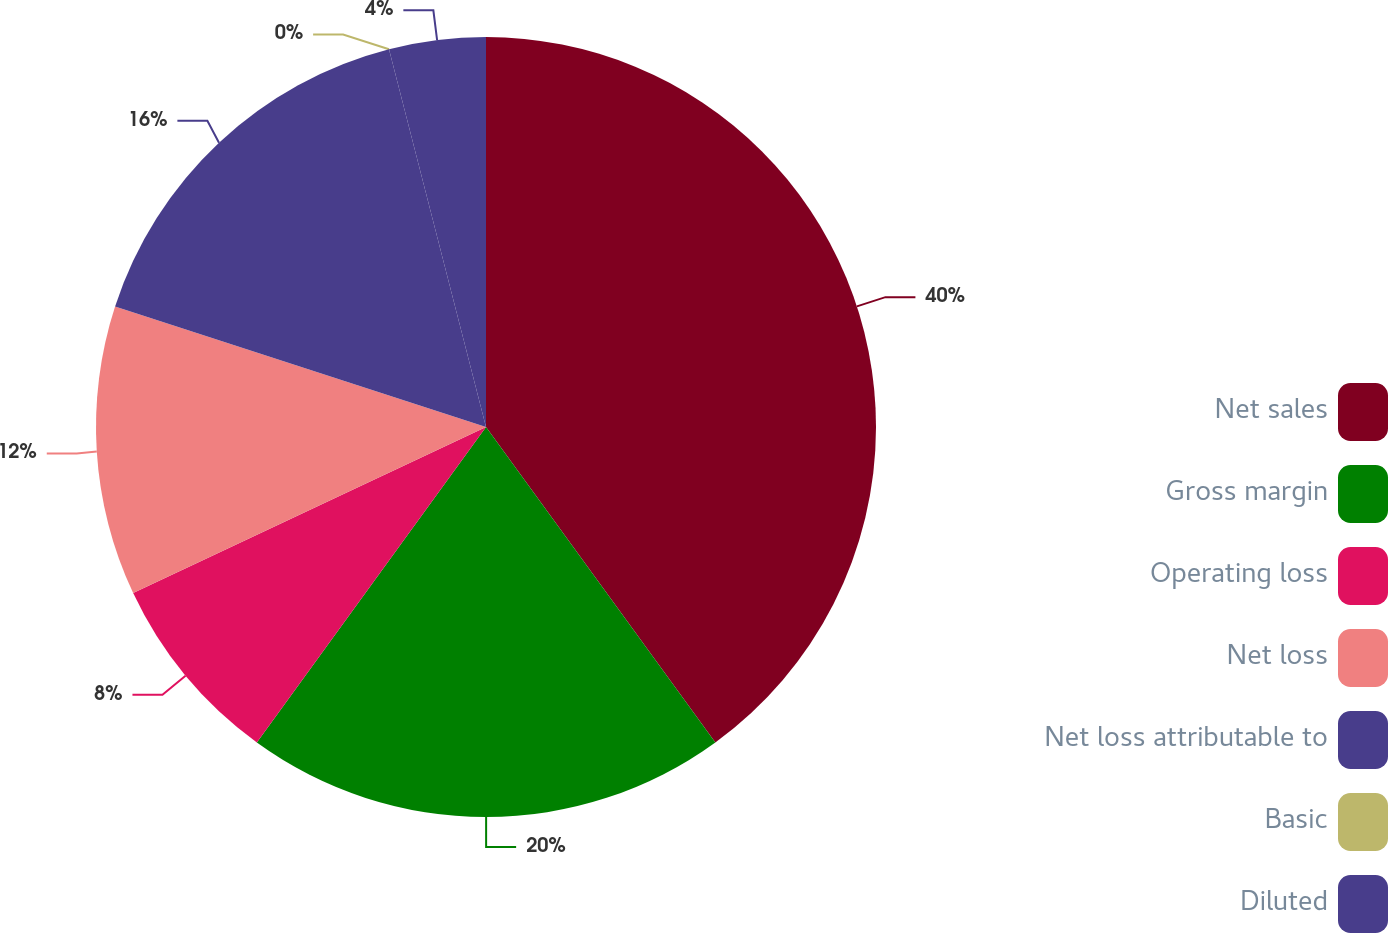<chart> <loc_0><loc_0><loc_500><loc_500><pie_chart><fcel>Net sales<fcel>Gross margin<fcel>Operating loss<fcel>Net loss<fcel>Net loss attributable to<fcel>Basic<fcel>Diluted<nl><fcel>39.99%<fcel>20.0%<fcel>8.0%<fcel>12.0%<fcel>16.0%<fcel>0.0%<fcel>4.0%<nl></chart> 